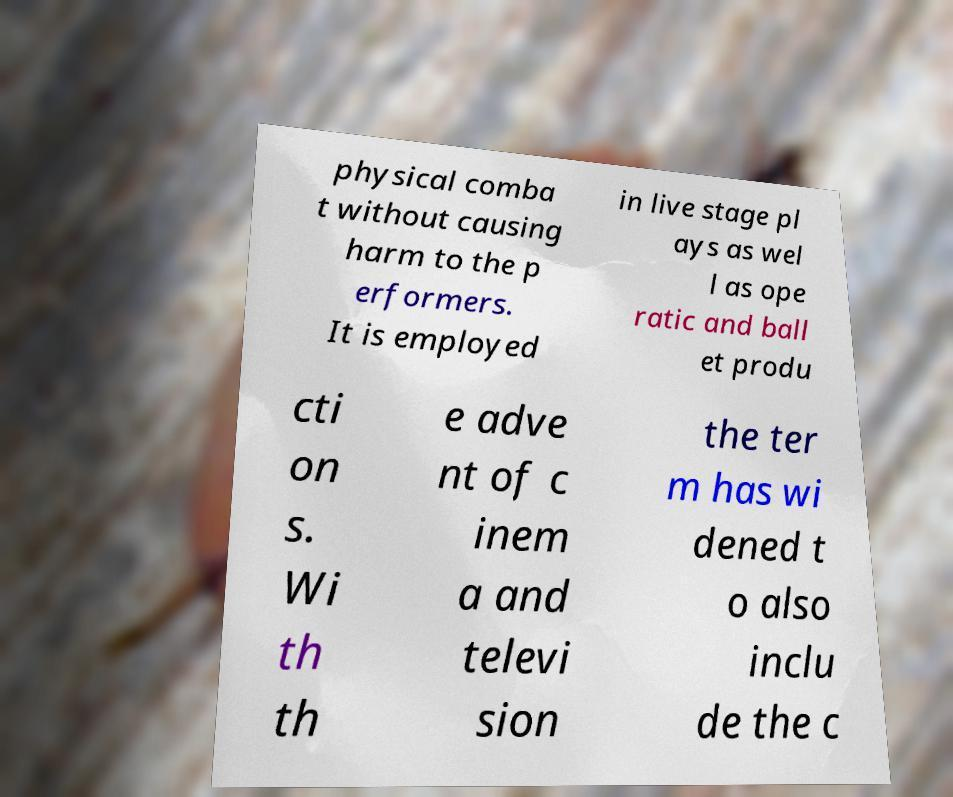Can you accurately transcribe the text from the provided image for me? physical comba t without causing harm to the p erformers. It is employed in live stage pl ays as wel l as ope ratic and ball et produ cti on s. Wi th th e adve nt of c inem a and televi sion the ter m has wi dened t o also inclu de the c 